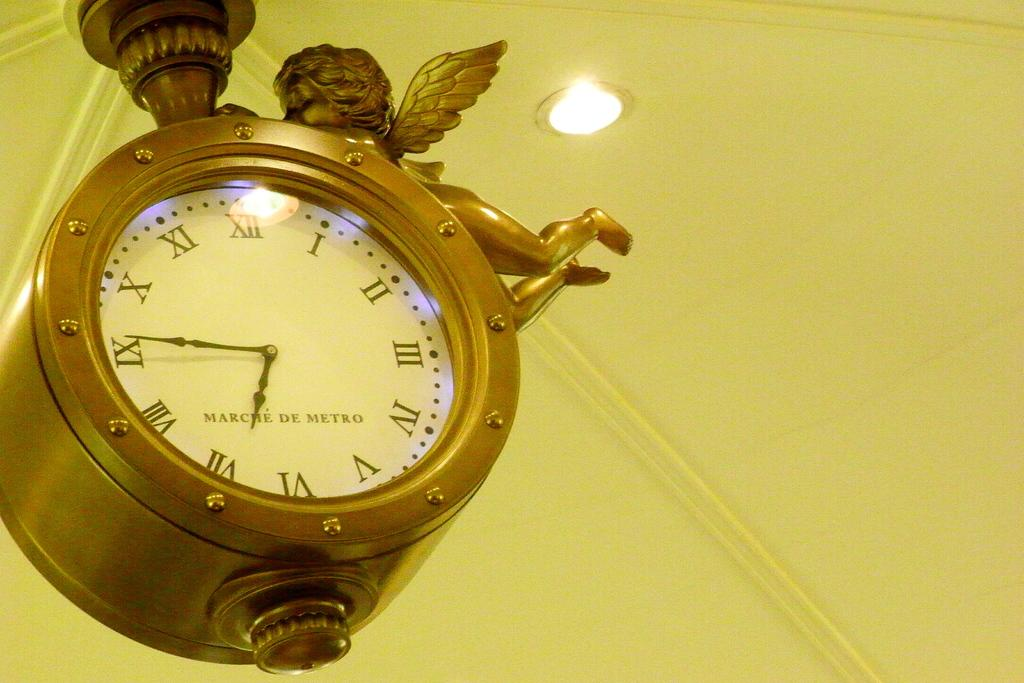<image>
Render a clear and concise summary of the photo. A bronze clock with an angel on it has the time of about 6:46. 